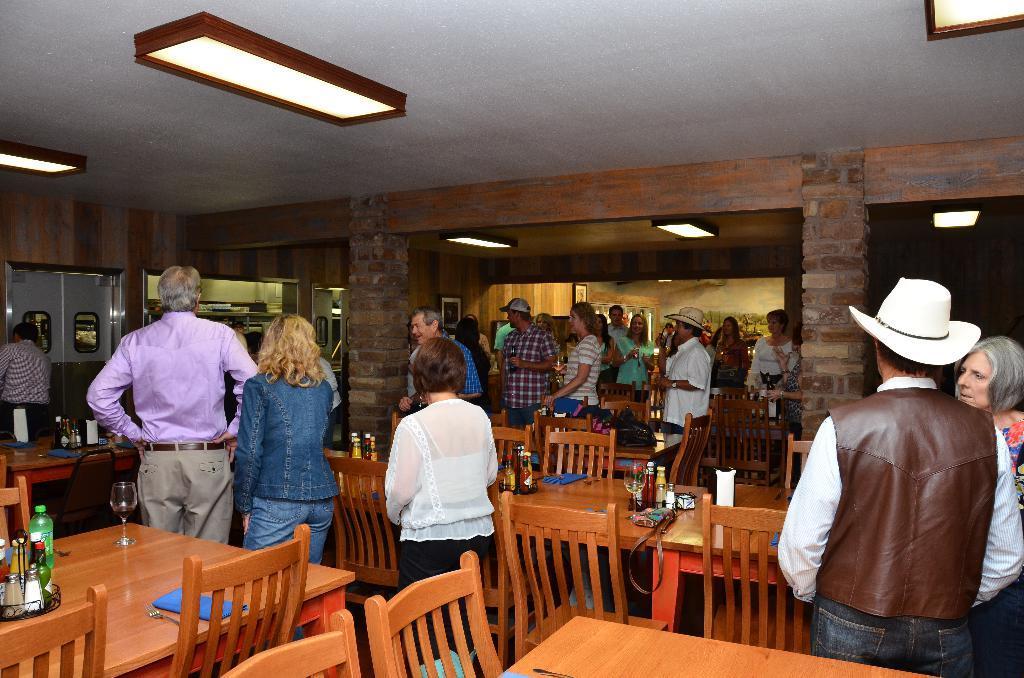In one or two sentences, can you explain what this image depicts? In a room there are many people standing. There is a table. On the table there are some bottles, glasses, handbags and chairs are there. And on the top there are some lights. We can see the pillars. And to the left corner there is a door. 